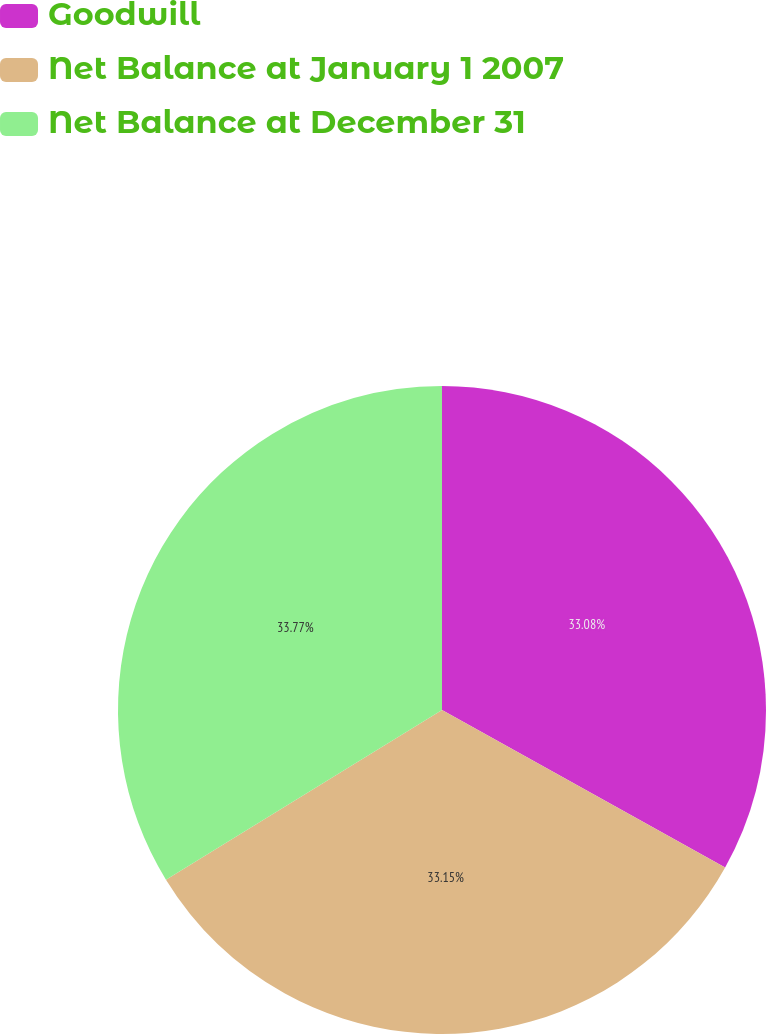<chart> <loc_0><loc_0><loc_500><loc_500><pie_chart><fcel>Goodwill<fcel>Net Balance at January 1 2007<fcel>Net Balance at December 31<nl><fcel>33.08%<fcel>33.15%<fcel>33.77%<nl></chart> 